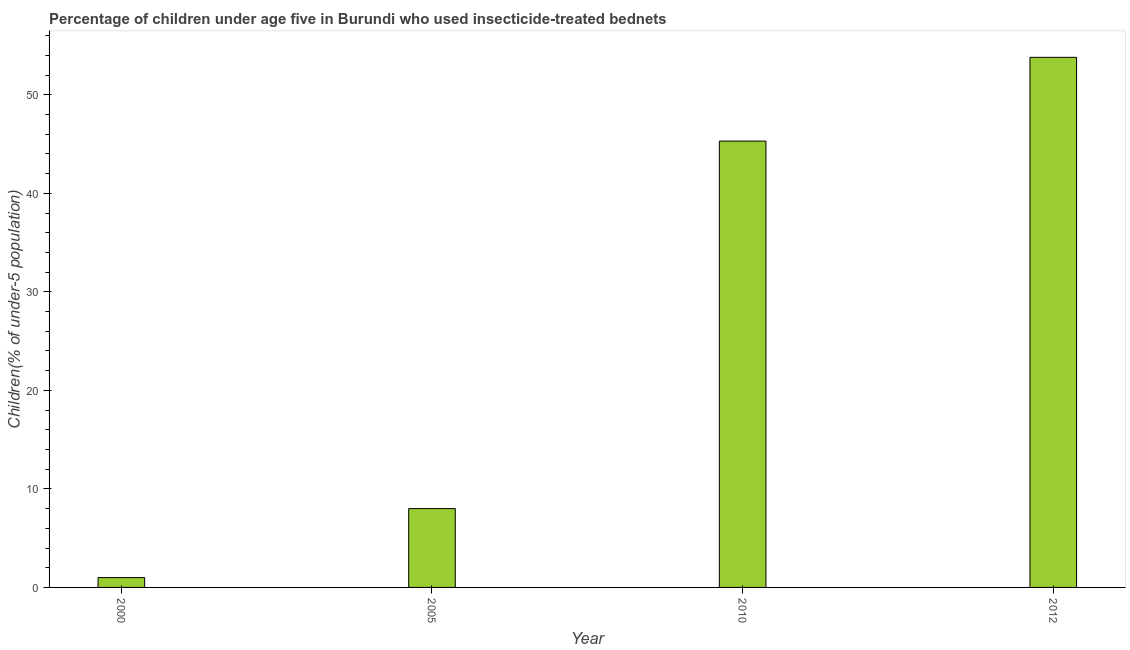Does the graph contain grids?
Your response must be concise. No. What is the title of the graph?
Your answer should be compact. Percentage of children under age five in Burundi who used insecticide-treated bednets. What is the label or title of the X-axis?
Offer a very short reply. Year. What is the label or title of the Y-axis?
Ensure brevity in your answer.  Children(% of under-5 population). What is the percentage of children who use of insecticide-treated bed nets in 2010?
Keep it short and to the point. 45.3. Across all years, what is the maximum percentage of children who use of insecticide-treated bed nets?
Provide a short and direct response. 53.8. In which year was the percentage of children who use of insecticide-treated bed nets maximum?
Give a very brief answer. 2012. In which year was the percentage of children who use of insecticide-treated bed nets minimum?
Provide a short and direct response. 2000. What is the sum of the percentage of children who use of insecticide-treated bed nets?
Give a very brief answer. 108.1. What is the difference between the percentage of children who use of insecticide-treated bed nets in 2000 and 2012?
Provide a succinct answer. -52.8. What is the average percentage of children who use of insecticide-treated bed nets per year?
Provide a succinct answer. 27.02. What is the median percentage of children who use of insecticide-treated bed nets?
Provide a short and direct response. 26.65. Do a majority of the years between 2010 and 2012 (inclusive) have percentage of children who use of insecticide-treated bed nets greater than 54 %?
Your answer should be very brief. No. What is the ratio of the percentage of children who use of insecticide-treated bed nets in 2005 to that in 2010?
Make the answer very short. 0.18. Is the percentage of children who use of insecticide-treated bed nets in 2000 less than that in 2010?
Give a very brief answer. Yes. Is the difference between the percentage of children who use of insecticide-treated bed nets in 2000 and 2012 greater than the difference between any two years?
Offer a terse response. Yes. What is the difference between the highest and the second highest percentage of children who use of insecticide-treated bed nets?
Your answer should be very brief. 8.5. Is the sum of the percentage of children who use of insecticide-treated bed nets in 2005 and 2012 greater than the maximum percentage of children who use of insecticide-treated bed nets across all years?
Provide a short and direct response. Yes. What is the difference between the highest and the lowest percentage of children who use of insecticide-treated bed nets?
Give a very brief answer. 52.8. What is the difference between two consecutive major ticks on the Y-axis?
Provide a short and direct response. 10. Are the values on the major ticks of Y-axis written in scientific E-notation?
Offer a terse response. No. What is the Children(% of under-5 population) in 2005?
Offer a terse response. 8. What is the Children(% of under-5 population) in 2010?
Your response must be concise. 45.3. What is the Children(% of under-5 population) in 2012?
Your response must be concise. 53.8. What is the difference between the Children(% of under-5 population) in 2000 and 2005?
Your response must be concise. -7. What is the difference between the Children(% of under-5 population) in 2000 and 2010?
Keep it short and to the point. -44.3. What is the difference between the Children(% of under-5 population) in 2000 and 2012?
Offer a very short reply. -52.8. What is the difference between the Children(% of under-5 population) in 2005 and 2010?
Keep it short and to the point. -37.3. What is the difference between the Children(% of under-5 population) in 2005 and 2012?
Provide a short and direct response. -45.8. What is the difference between the Children(% of under-5 population) in 2010 and 2012?
Offer a terse response. -8.5. What is the ratio of the Children(% of under-5 population) in 2000 to that in 2010?
Your response must be concise. 0.02. What is the ratio of the Children(% of under-5 population) in 2000 to that in 2012?
Your answer should be compact. 0.02. What is the ratio of the Children(% of under-5 population) in 2005 to that in 2010?
Ensure brevity in your answer.  0.18. What is the ratio of the Children(% of under-5 population) in 2005 to that in 2012?
Make the answer very short. 0.15. What is the ratio of the Children(% of under-5 population) in 2010 to that in 2012?
Offer a terse response. 0.84. 